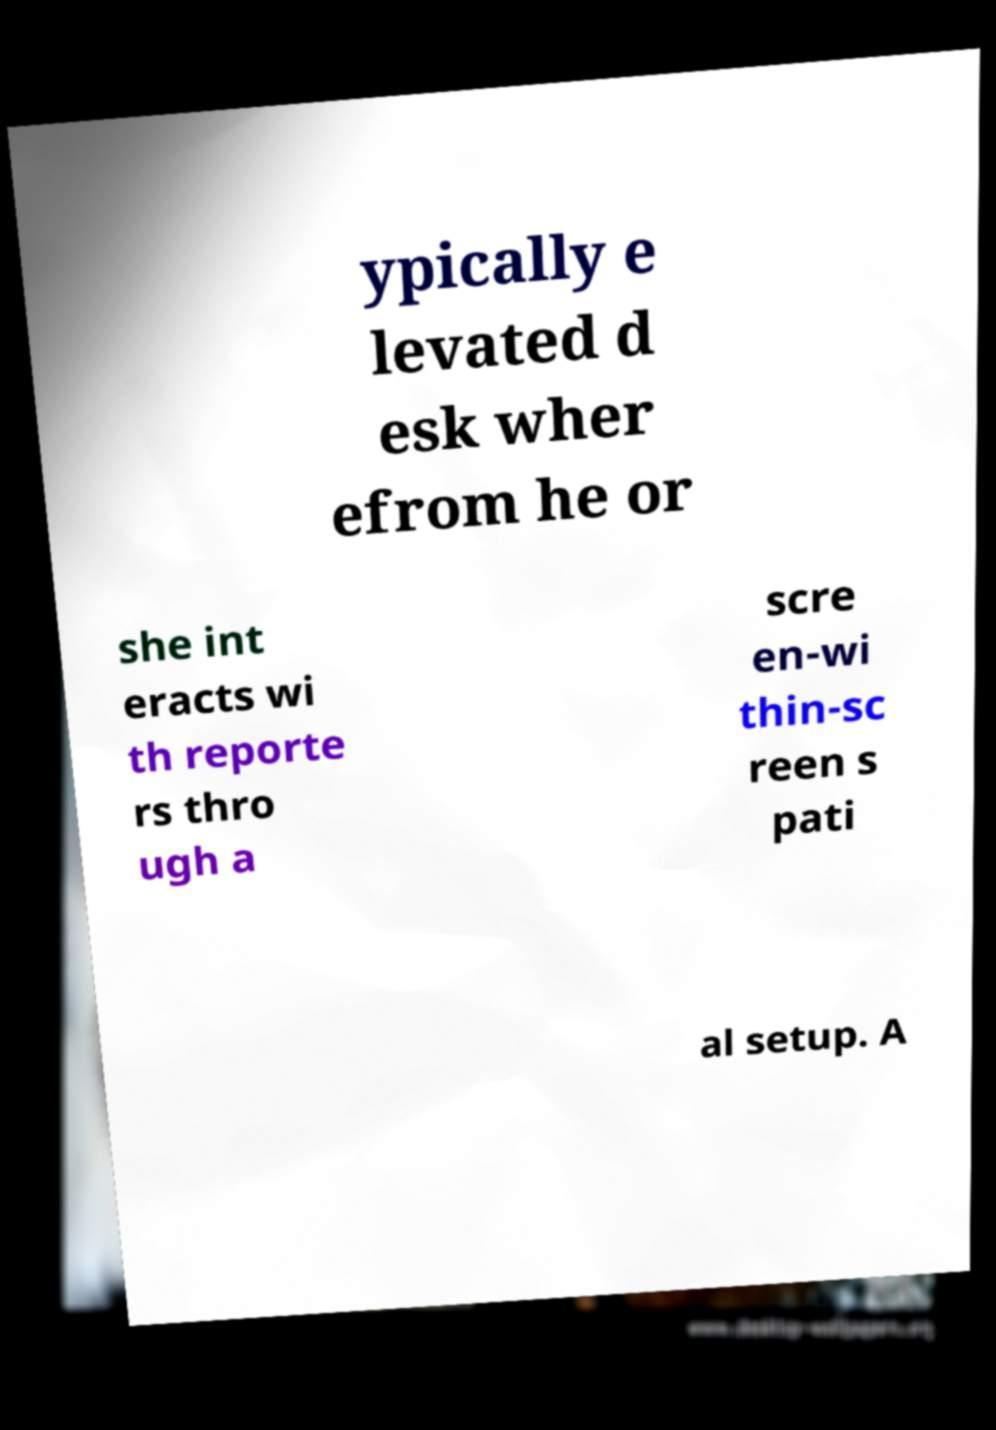What messages or text are displayed in this image? I need them in a readable, typed format. ypically e levated d esk wher efrom he or she int eracts wi th reporte rs thro ugh a scre en-wi thin-sc reen s pati al setup. A 